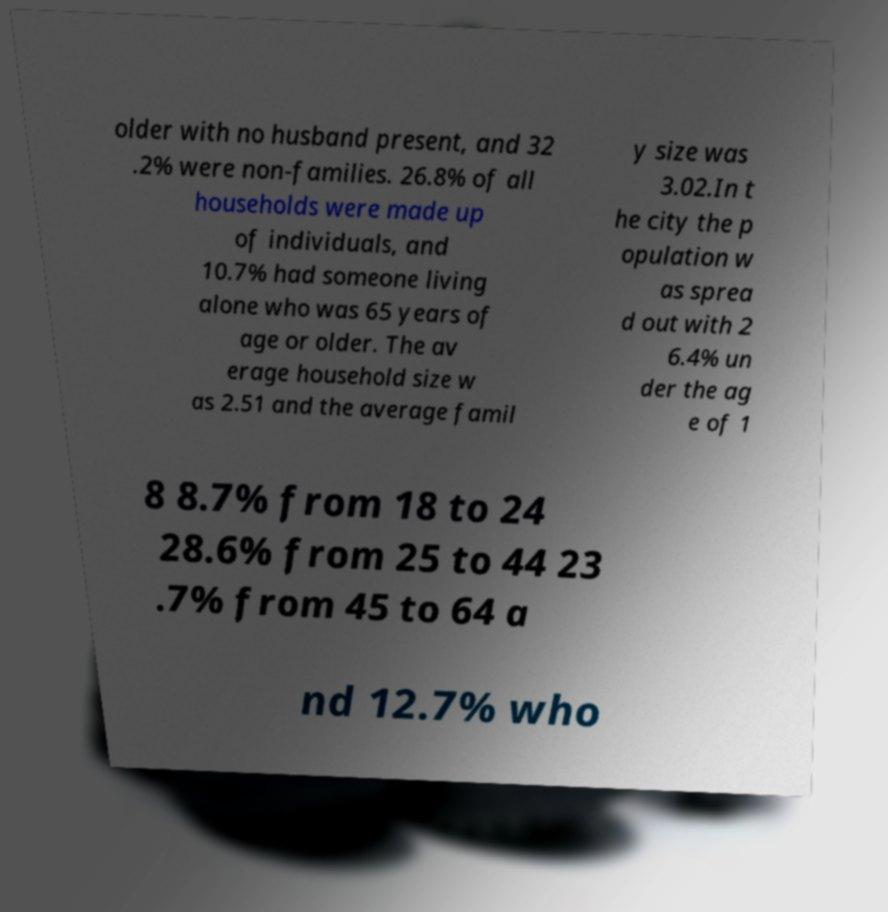Can you read and provide the text displayed in the image?This photo seems to have some interesting text. Can you extract and type it out for me? older with no husband present, and 32 .2% were non-families. 26.8% of all households were made up of individuals, and 10.7% had someone living alone who was 65 years of age or older. The av erage household size w as 2.51 and the average famil y size was 3.02.In t he city the p opulation w as sprea d out with 2 6.4% un der the ag e of 1 8 8.7% from 18 to 24 28.6% from 25 to 44 23 .7% from 45 to 64 a nd 12.7% who 